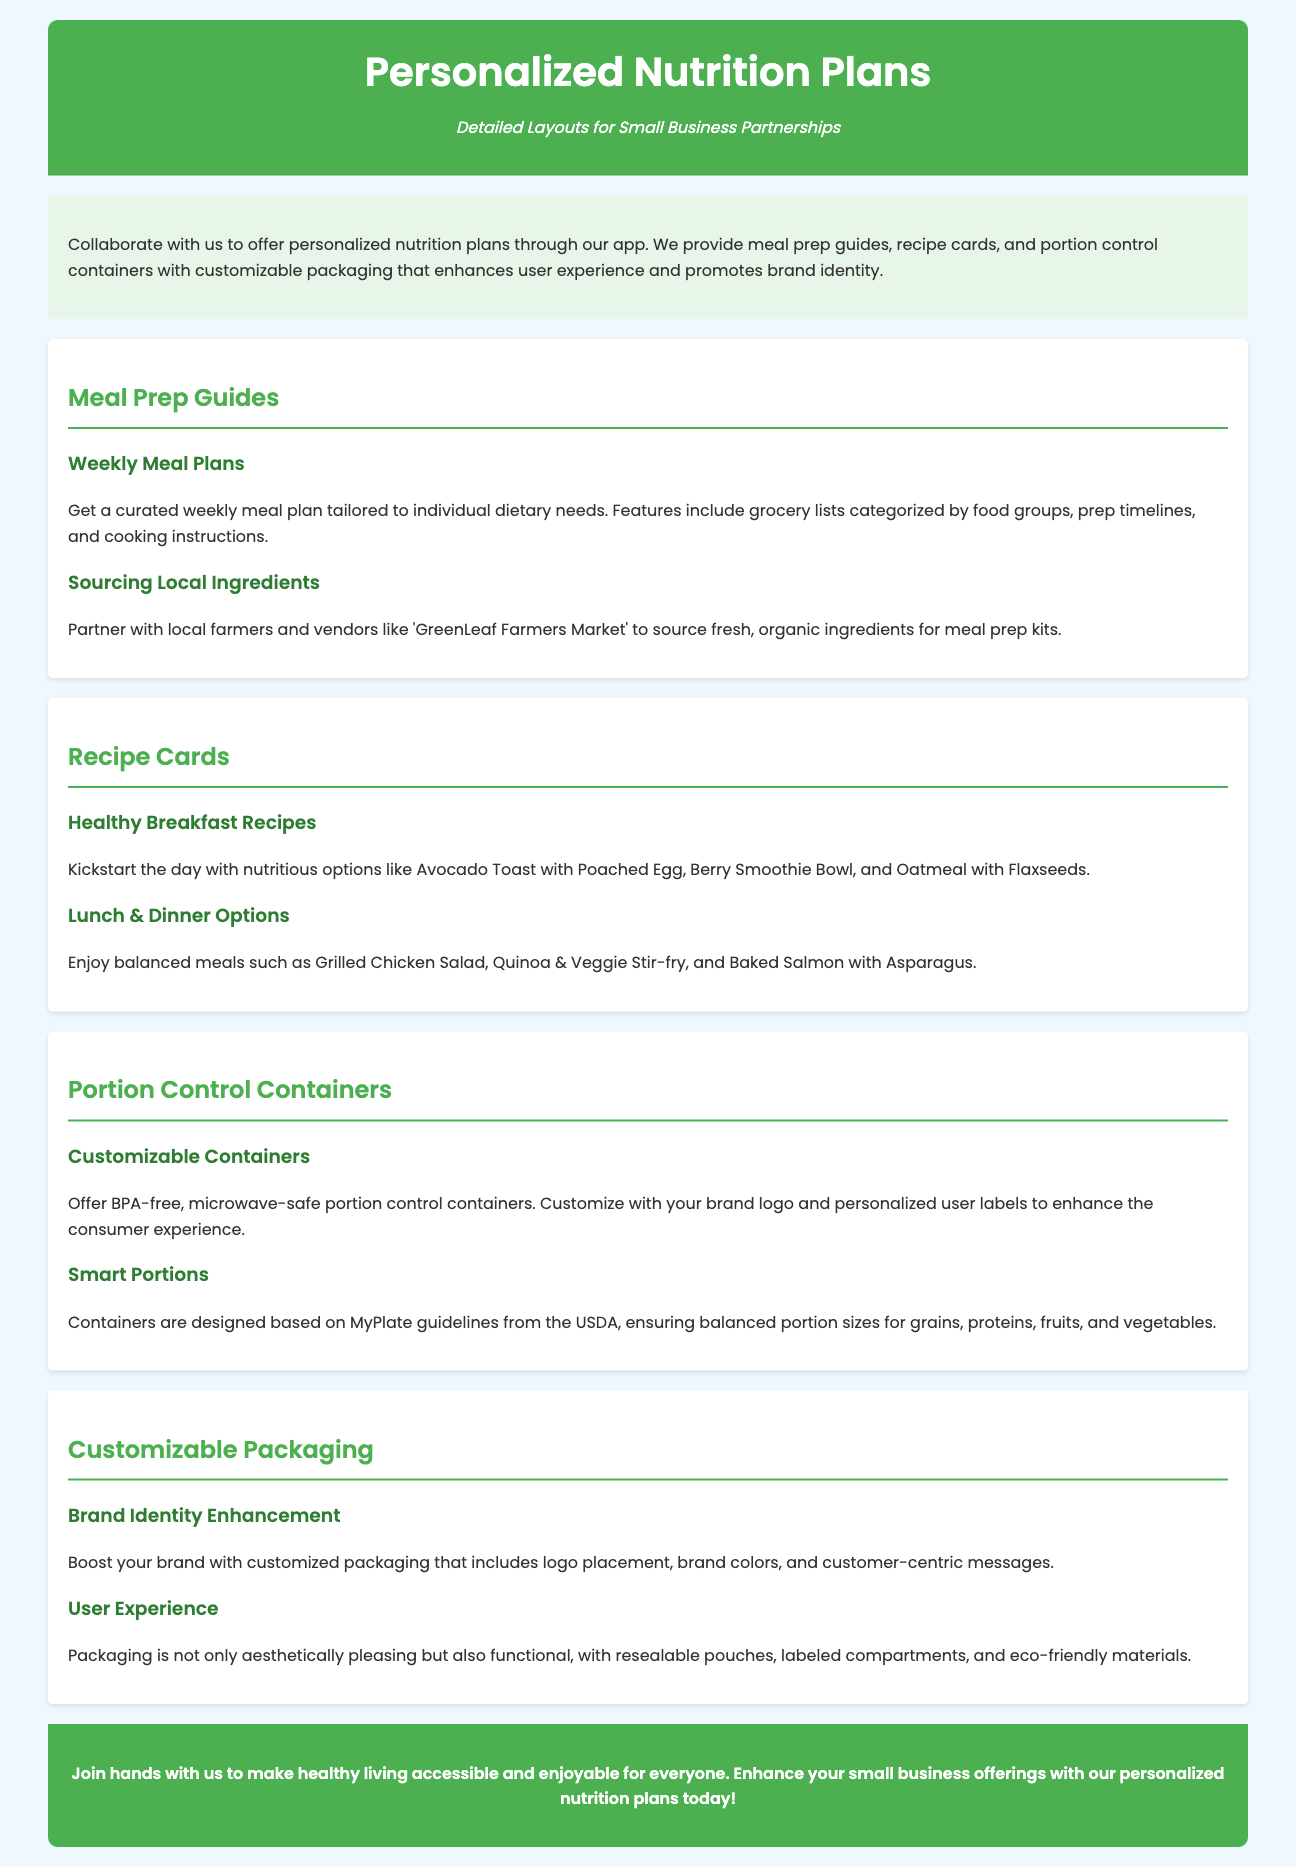What are meal prep guides? Meal prep guides are curated weekly meal plans tailored to individual dietary needs, including grocery lists, prep timelines, and cooking instructions.
Answer: Weekly meal plans Who can we partner with for local ingredients? The document mentions 'GreenLeaf Farmers Market' as a local vendor for fresh, organic ingredients.
Answer: GreenLeaf Farmers Market What type of recipes are included for breakfast? The document lists options like Avocado Toast with Poached Egg, Berry Smoothie Bowl, and Oatmeal with Flaxseeds under breakfast recipes.
Answer: Avocado Toast with Poached Egg What materials are the portion control containers made from? The document specifies that the portion control containers are BPA-free and microwave-safe.
Answer: BPA-free, microwave-safe How does customizable packaging enhance user experience? Customizable packaging is described as aesthetically pleasing and functional, with resealable pouches, labeled compartments, and eco-friendly materials.
Answer: Aesthetically pleasing, functional What guidelines are the containers designed based on? The containers are designed based on MyPlate guidelines from the USDA to ensure balanced portion sizes.
Answer: MyPlate guidelines What is a benefit of brand identity enhancement? The document states that it boosts your brand with customized packaging that includes logo placement and brand colors.
Answer: Boosts your brand How can small businesses make healthy living accessible? The footer emphasizes collaboration to enhance small business offerings with personalized nutrition plans.
Answer: Collaboration for personalized nutrition plans 